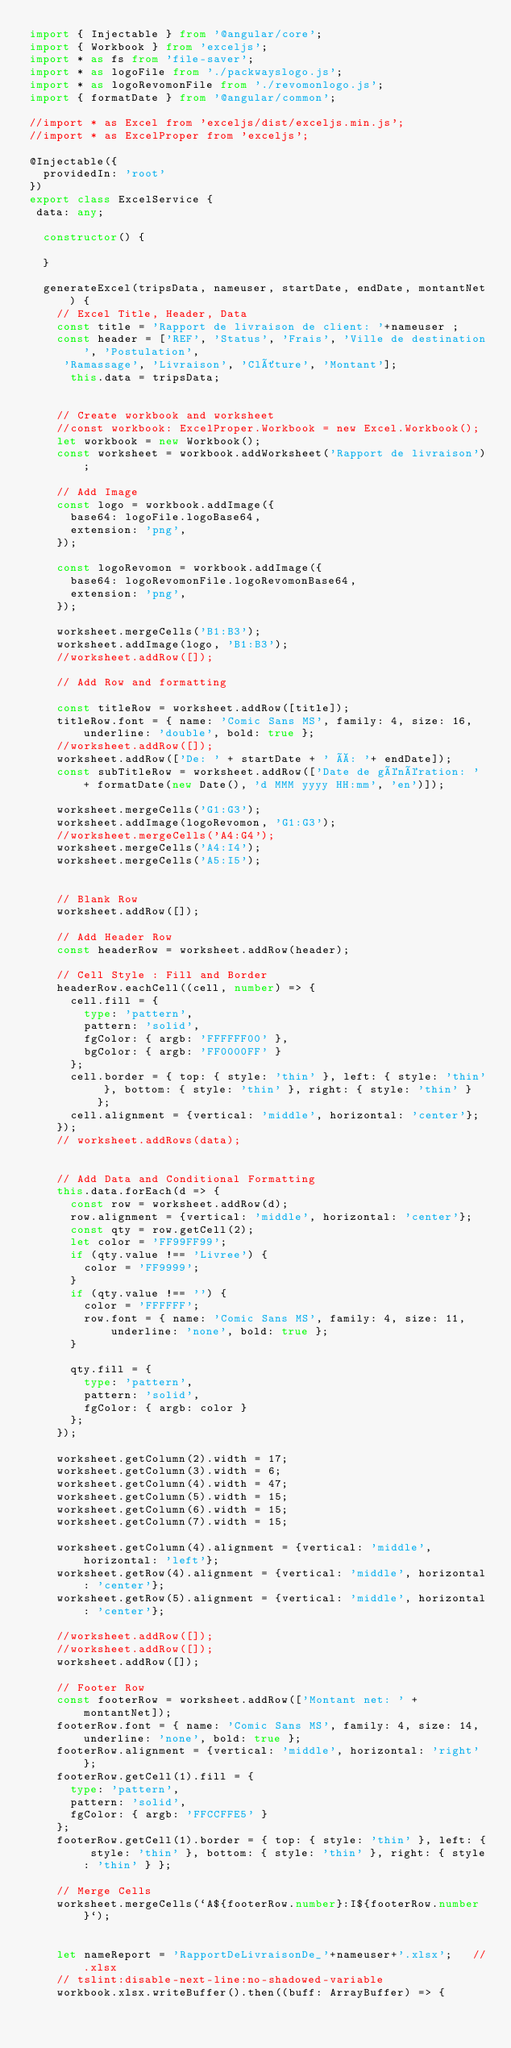Convert code to text. <code><loc_0><loc_0><loc_500><loc_500><_TypeScript_>import { Injectable } from '@angular/core';
import { Workbook } from 'exceljs';
import * as fs from 'file-saver';
import * as logoFile from './packwayslogo.js';
import * as logoRevomonFile from './revomonlogo.js';
import { formatDate } from '@angular/common';

//import * as Excel from 'exceljs/dist/exceljs.min.js';
//import * as ExcelProper from 'exceljs';

@Injectable({
  providedIn: 'root'
})
export class ExcelService {
 data: any; 

  constructor() {

  }

  generateExcel(tripsData, nameuser, startDate, endDate, montantNet) {
    // Excel Title, Header, Data
    const title = 'Rapport de livraison de client: '+nameuser ;
    const header = ['REF', 'Status', 'Frais', 'Ville de destination', 'Postulation',
     'Ramassage', 'Livraison', 'Clôture', 'Montant'];
      this.data = tripsData;


    // Create workbook and worksheet
    //const workbook: ExcelProper.Workbook = new Excel.Workbook();
    let workbook = new Workbook();
    const worksheet = workbook.addWorksheet('Rapport de livraison');

    // Add Image
    const logo = workbook.addImage({
      base64: logoFile.logoBase64,
      extension: 'png',
    });

    const logoRevomon = workbook.addImage({
      base64: logoRevomonFile.logoRevomonBase64,
      extension: 'png',
    });

    worksheet.mergeCells('B1:B3');
    worksheet.addImage(logo, 'B1:B3');
    //worksheet.addRow([]);    

    // Add Row and formatting
  
    const titleRow = worksheet.addRow([title]);
    titleRow.font = { name: 'Comic Sans MS', family: 4, size: 16, underline: 'double', bold: true };
    //worksheet.addRow([]);
    worksheet.addRow(['De: ' + startDate + ' À: '+ endDate]);
    const subTitleRow = worksheet.addRow(['Date de génération: ' + formatDate(new Date(), 'd MMM yyyy HH:mm', 'en')]);

    worksheet.mergeCells('G1:G3');
    worksheet.addImage(logoRevomon, 'G1:G3');
    //worksheet.mergeCells('A4:G4');
    worksheet.mergeCells('A4:I4');
    worksheet.mergeCells('A5:I5');    


    // Blank Row
    worksheet.addRow([]);

    // Add Header Row
    const headerRow = worksheet.addRow(header);

    // Cell Style : Fill and Border
    headerRow.eachCell((cell, number) => {
      cell.fill = {
        type: 'pattern',
        pattern: 'solid',
        fgColor: { argb: 'FFFFFF00' },
        bgColor: { argb: 'FF0000FF' }
      };
      cell.border = { top: { style: 'thin' }, left: { style: 'thin' }, bottom: { style: 'thin' }, right: { style: 'thin' } };
      cell.alignment = {vertical: 'middle', horizontal: 'center'};
    });
    // worksheet.addRows(data);


    // Add Data and Conditional Formatting
    this.data.forEach(d => {
      const row = worksheet.addRow(d);
      row.alignment = {vertical: 'middle', horizontal: 'center'};
      const qty = row.getCell(2);
      let color = 'FF99FF99';
      if (qty.value !== 'Livree') {
        color = 'FF9999';
      }
      if (qty.value !== '') {
        color = 'FFFFFF';
        row.font = { name: 'Comic Sans MS', family: 4, size: 11, underline: 'none', bold: true };
      }

      qty.fill = {
        type: 'pattern',
        pattern: 'solid',
        fgColor: { argb: color }
      }; 
    });
    
    worksheet.getColumn(2).width = 17;
    worksheet.getColumn(3).width = 6;
    worksheet.getColumn(4).width = 47;
    worksheet.getColumn(5).width = 15;
    worksheet.getColumn(6).width = 15;
    worksheet.getColumn(7).width = 15;

    worksheet.getColumn(4).alignment = {vertical: 'middle', horizontal: 'left'};
    worksheet.getRow(4).alignment = {vertical: 'middle', horizontal: 'center'};
    worksheet.getRow(5).alignment = {vertical: 'middle', horizontal: 'center'};    

    //worksheet.addRow([]);
    //worksheet.addRow([]);
    worksheet.addRow([]);

    // Footer Row
    const footerRow = worksheet.addRow(['Montant net: ' + montantNet]);
    footerRow.font = { name: 'Comic Sans MS', family: 4, size: 14, underline: 'none', bold: true };
    footerRow.alignment = {vertical: 'middle', horizontal: 'right'};
    footerRow.getCell(1).fill = {
      type: 'pattern',
      pattern: 'solid',
      fgColor: { argb: 'FFCCFFE5' }
    };
    footerRow.getCell(1).border = { top: { style: 'thin' }, left: { style: 'thin' }, bottom: { style: 'thin' }, right: { style: 'thin' } };

    // Merge Cells
    worksheet.mergeCells(`A${footerRow.number}:I${footerRow.number}`);


    let nameReport = 'RapportDeLivraisonDe_'+nameuser+'.xlsx';   //.xlsx
    // tslint:disable-next-line:no-shadowed-variable
    workbook.xlsx.writeBuffer().then((buff: ArrayBuffer) => {</code> 